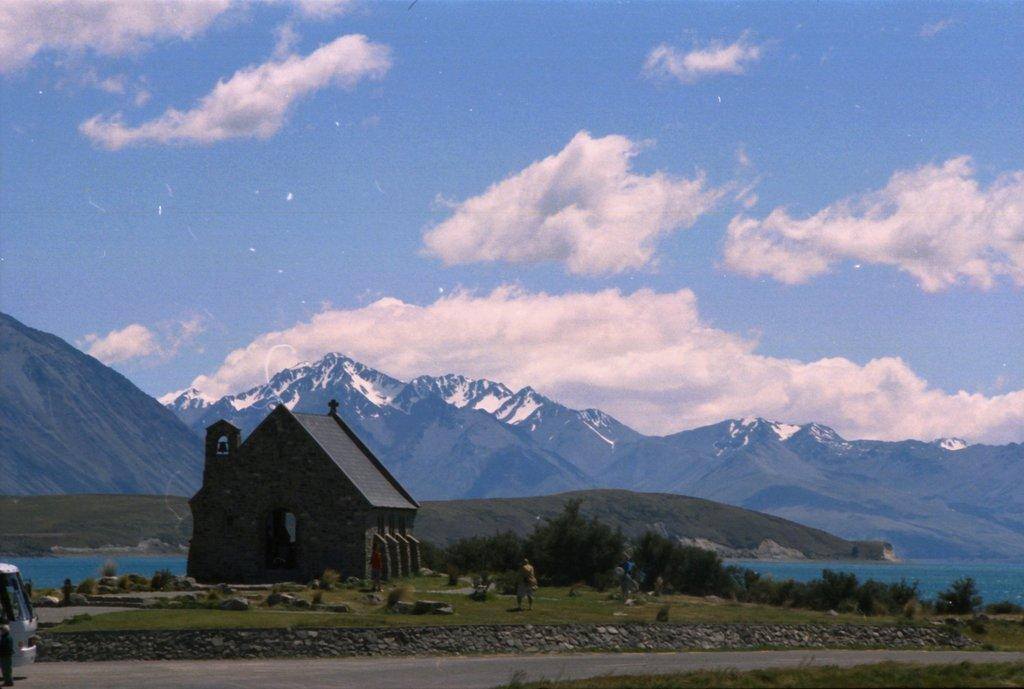What type of structure is present in the image? There is a house in the image. Can you describe the person in the image? There is a person in the image. What type of natural elements can be seen in the image? There are stones, plants, water, grass, and mountains visible in the image. What is the mode of transportation in the image? There is a vehicle in the image. What can be seen in the background of the image? The sky is visible in the background of the image, and there are clouds in the sky. What type of reward is the person receiving from the house in the image? There is no indication in the image that the person is receiving a reward from the house. How many birds are visible in the image? There are no birds visible in the image. 